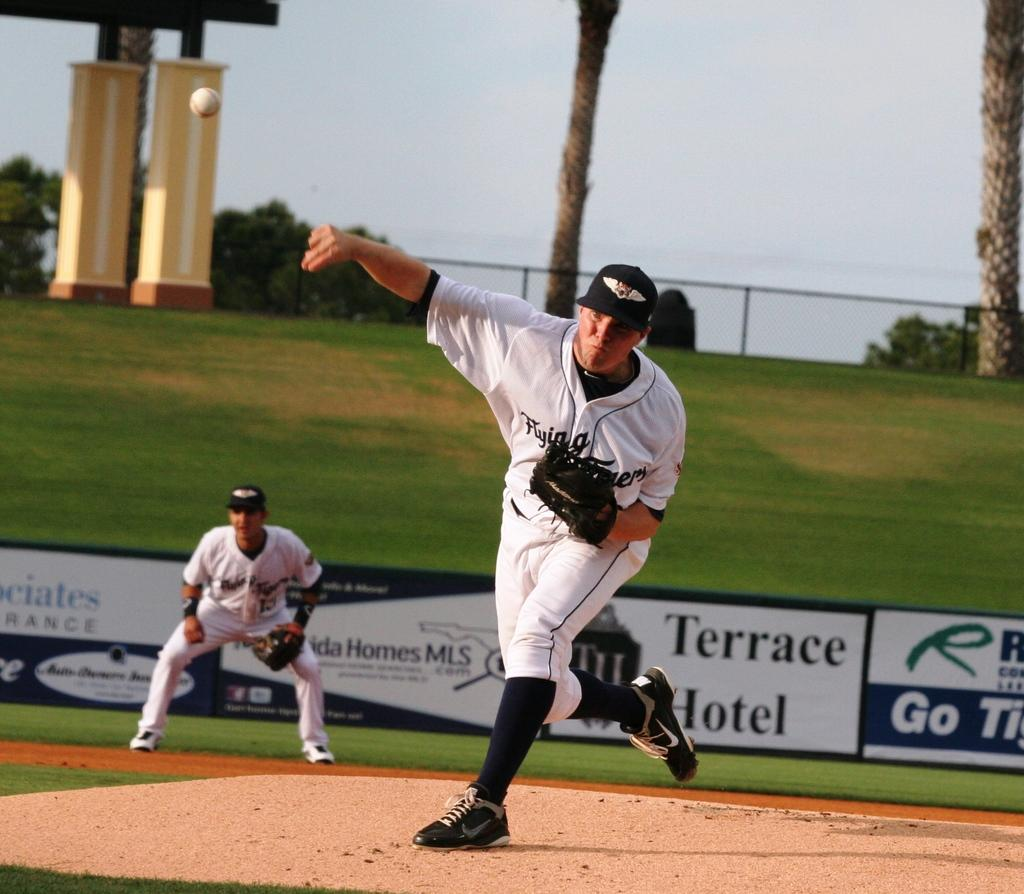Provide a one-sentence caption for the provided image. A man throwing a ball on a field sponsored by Terrace Hotel. 